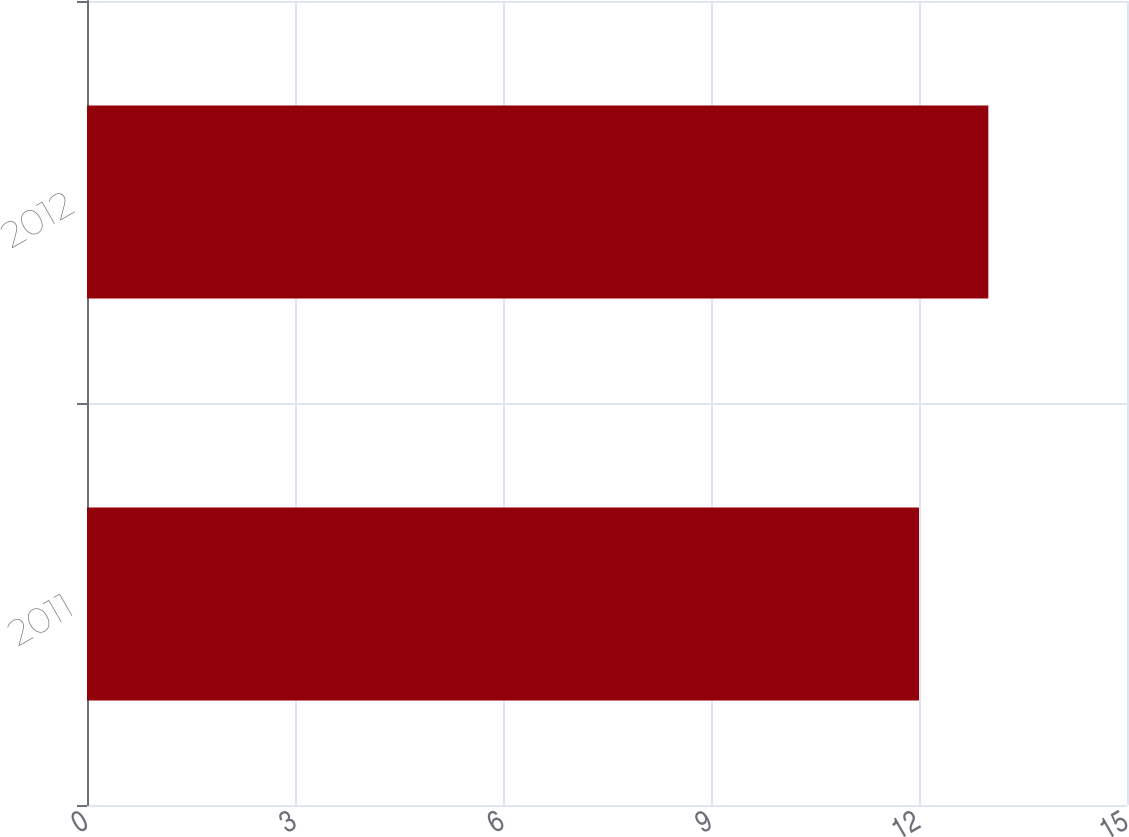Convert chart to OTSL. <chart><loc_0><loc_0><loc_500><loc_500><bar_chart><fcel>2011<fcel>2012<nl><fcel>12<fcel>13<nl></chart> 